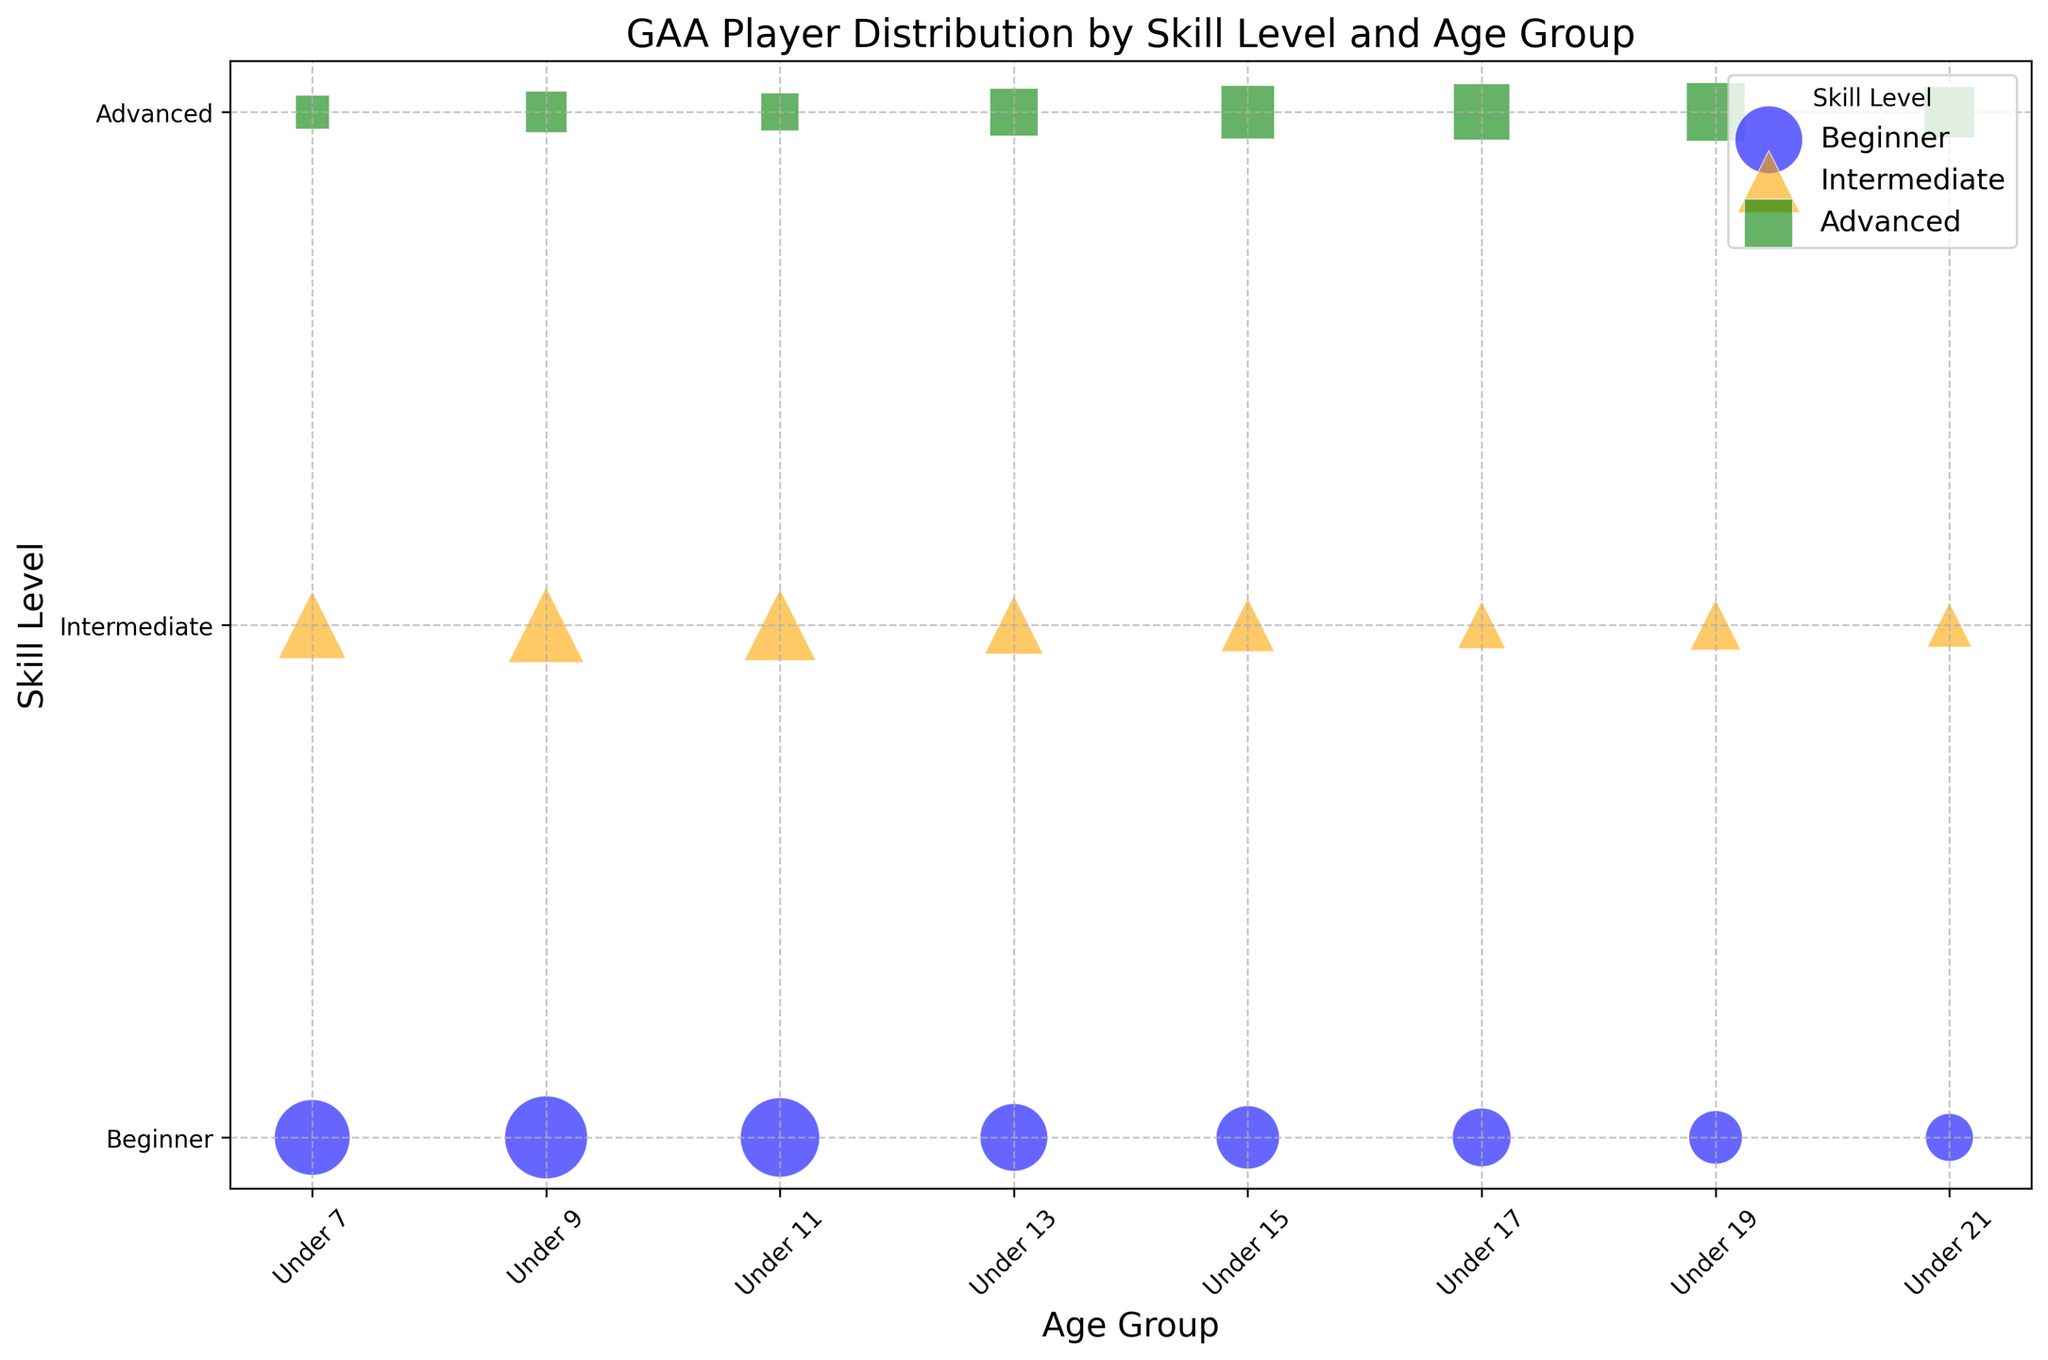What age group has the largest number of beginners? First, observe the blue bubbles (representing beginners) and compare their sizes across different age groups. The largest bubble in blue appears in the Under 9 age group. This indicates the highest number of beginner players.
Answer: Under 9 Which age group has the fewest advanced players? Look at the green bubbles (representing advanced players) and find the smallest one. The smallest green bubble is found in the Under 7 age group.
Answer: Under 7 Compare the number of intermediate players in the Under 11 and Under 15 age groups. Which group has more? Find the orange bubbles (representing intermediate players) for both Under 11 and Under 15. Compare their sizes. Under 11 has more intermediate players than Under 15.
Answer: Under 11 How does the number of advanced players in the Under 19 age group compare to the number of beginners in the same age group? Find the green bubble for advanced players and the blue bubble for beginners in the Under 19 age group. The green bubble is larger, indicating more advanced players than beginners.
Answer: More advanced players What is the combined total number of players in the Under 13 age group across all skill levels? To find the combined total, add the sizes of the bubbles for Under 13 across all three skill levels. The numbers are 80 (Beginner) + 60 (Intermediate) + 40 (Advanced) = 180.
Answer: 180 Which skill level has the most balanced distribution of players across all age groups? Observe the consistency in bubble sizes for each skill level across all age groups. Intermediate players (orange bubbles) show relatively consistent bubble sizes across age groups.
Answer: Intermediate In the Under 17 age group, is there a higher number of advanced players or intermediate players? Compare the sizes of the green (advanced) and orange (intermediate) bubbles in the Under 17 age group. The green bubble is larger, indicating more advanced players.
Answer: Advanced How does the number of players in the Under 21 age group compare among different skill levels? Compare the bubble sizes in the Under 21 age group for blue (Beginner), orange (Intermediate), and green (Advanced). The sizes are in the following order: Advanced > Beginner > Intermediate.
Answer: Advanced > Beginner > Intermediate Which age group has the highest total number of intermediate and advanced players combined? Add the values of the orange and green bubbles for each age group. The highest combined count appears in the Under 9 age group: Intermediate (100) + Advanced (30) = 130.
Answer: Under 9 